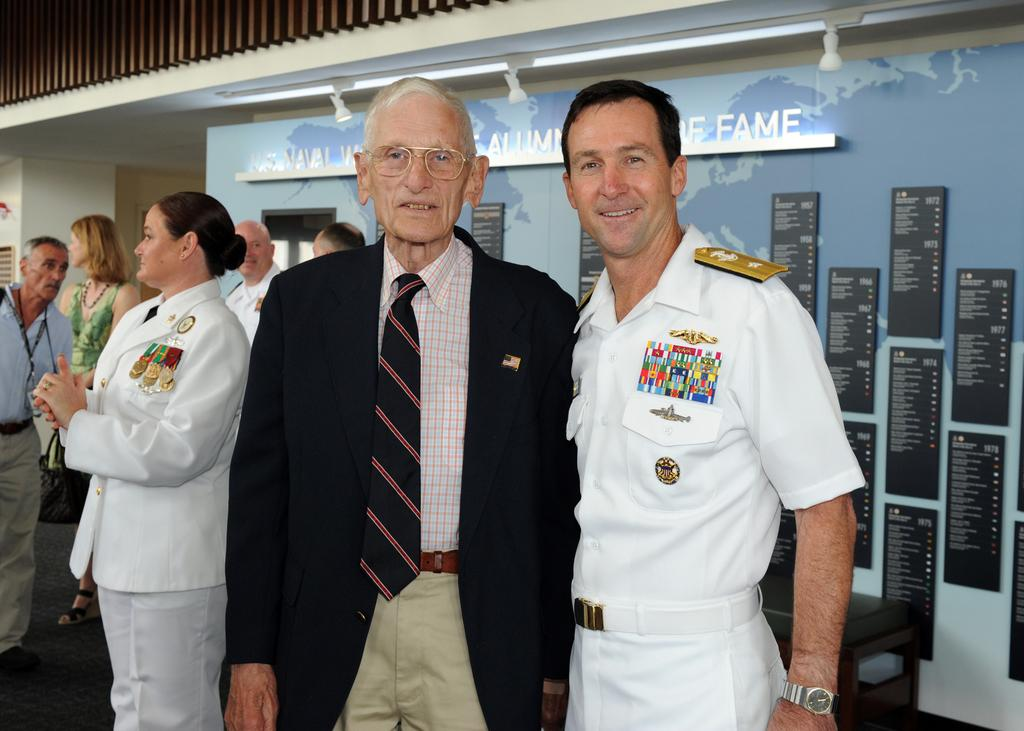<image>
Write a terse but informative summary of the picture. An old man and a younger one smile for the picture and behind them there is a wall with the word fame. 